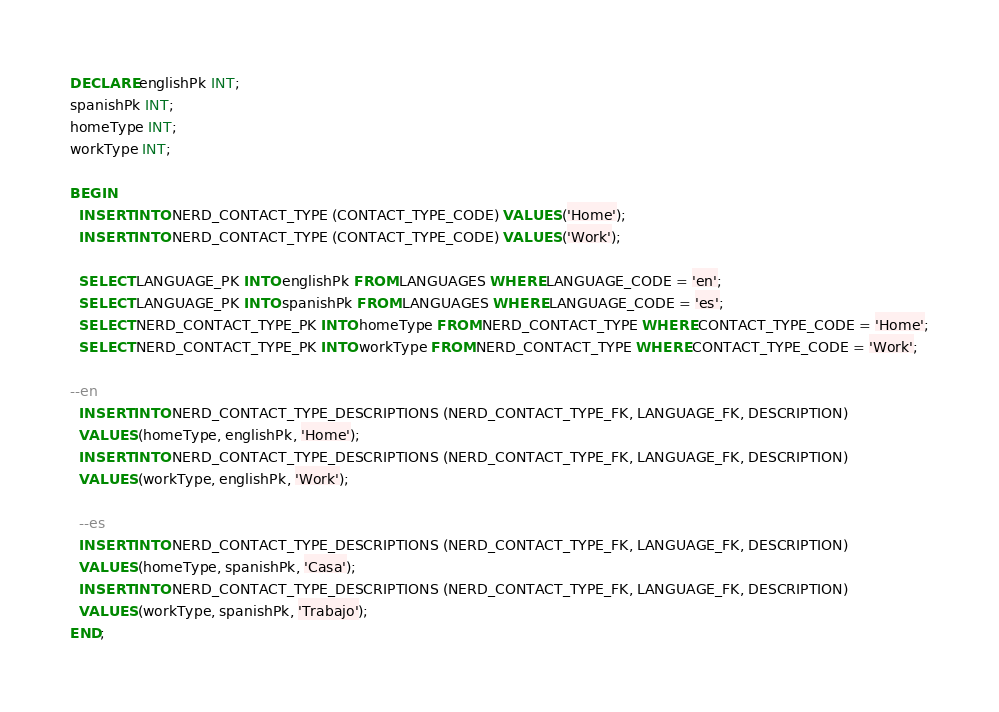Convert code to text. <code><loc_0><loc_0><loc_500><loc_500><_SQL_>DECLARE englishPk INT;
spanishPk INT;
homeType INT;
workType INT;

BEGIN
  INSERT INTO NERD_CONTACT_TYPE (CONTACT_TYPE_CODE) VALUES ('Home');
  INSERT INTO NERD_CONTACT_TYPE (CONTACT_TYPE_CODE) VALUES ('Work');

  SELECT LANGUAGE_PK INTO englishPk FROM LANGUAGES WHERE LANGUAGE_CODE = 'en';
  SELECT LANGUAGE_PK INTO spanishPk FROM LANGUAGES WHERE LANGUAGE_CODE = 'es';
  SELECT NERD_CONTACT_TYPE_PK INTO homeType FROM NERD_CONTACT_TYPE WHERE CONTACT_TYPE_CODE = 'Home';
  SELECT NERD_CONTACT_TYPE_PK INTO workType FROM NERD_CONTACT_TYPE WHERE CONTACT_TYPE_CODE = 'Work';

--en
  INSERT INTO NERD_CONTACT_TYPE_DESCRIPTIONS (NERD_CONTACT_TYPE_FK, LANGUAGE_FK, DESCRIPTION)
  VALUES (homeType, englishPk, 'Home');
  INSERT INTO NERD_CONTACT_TYPE_DESCRIPTIONS (NERD_CONTACT_TYPE_FK, LANGUAGE_FK, DESCRIPTION)
  VALUES (workType, englishPk, 'Work');

  --es
  INSERT INTO NERD_CONTACT_TYPE_DESCRIPTIONS (NERD_CONTACT_TYPE_FK, LANGUAGE_FK, DESCRIPTION)
  VALUES (homeType, spanishPk, 'Casa');
  INSERT INTO NERD_CONTACT_TYPE_DESCRIPTIONS (NERD_CONTACT_TYPE_FK, LANGUAGE_FK, DESCRIPTION)
  VALUES (workType, spanishPk, 'Trabajo');
END;</code> 